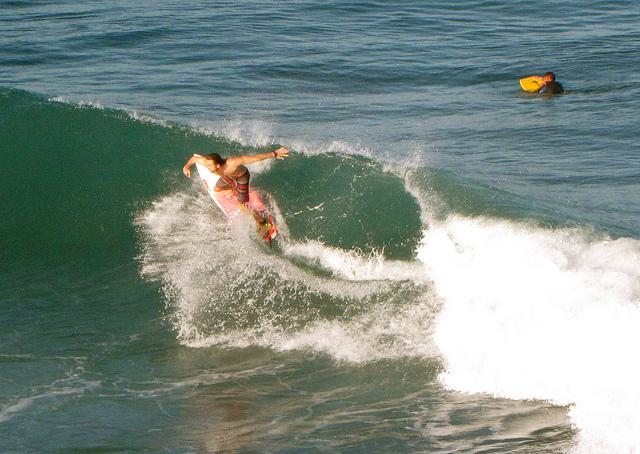Which wrist has a black band?
Give a very brief answer. Left. Are both surfer's on their surfboards?
Be succinct. No. How many people?
Keep it brief. 2. 